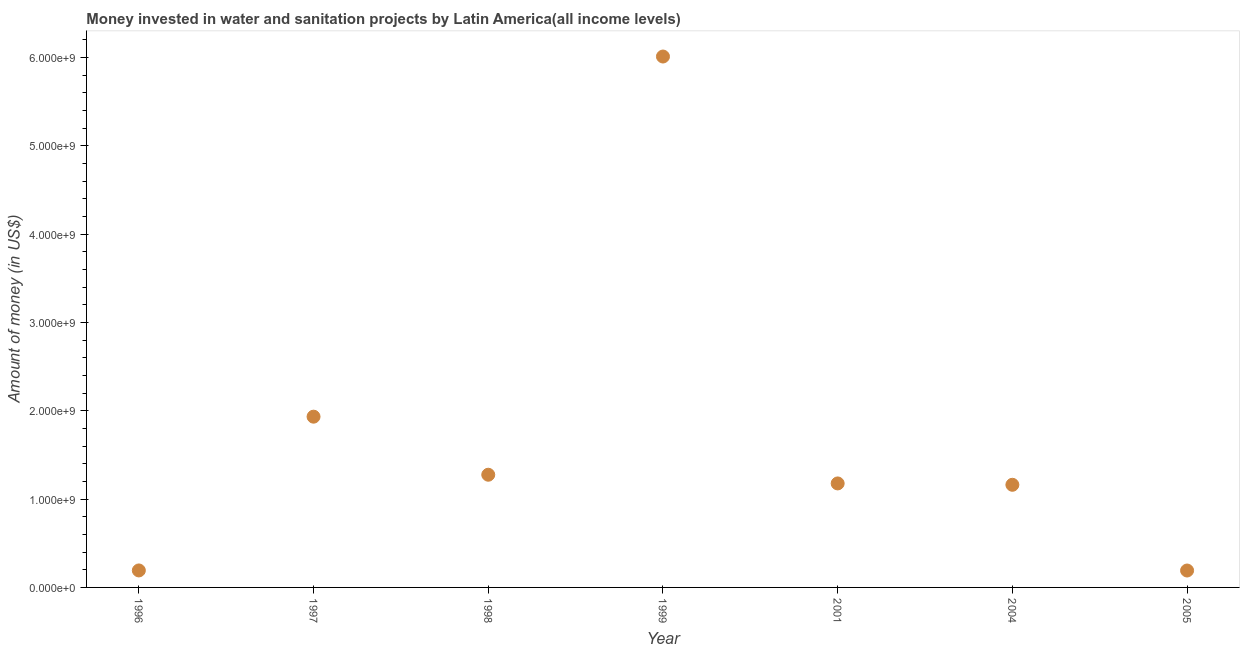What is the investment in 1996?
Make the answer very short. 1.92e+08. Across all years, what is the maximum investment?
Offer a very short reply. 6.01e+09. Across all years, what is the minimum investment?
Provide a succinct answer. 1.91e+08. In which year was the investment maximum?
Provide a succinct answer. 1999. What is the sum of the investment?
Give a very brief answer. 1.19e+1. What is the difference between the investment in 1998 and 2004?
Your answer should be very brief. 1.14e+08. What is the average investment per year?
Your response must be concise. 1.71e+09. What is the median investment?
Your answer should be compact. 1.18e+09. In how many years, is the investment greater than 4600000000 US$?
Provide a short and direct response. 1. Do a majority of the years between 1999 and 2004 (inclusive) have investment greater than 2800000000 US$?
Provide a succinct answer. No. What is the ratio of the investment in 1999 to that in 2005?
Provide a short and direct response. 31.4. Is the difference between the investment in 1996 and 2005 greater than the difference between any two years?
Offer a terse response. No. What is the difference between the highest and the second highest investment?
Your answer should be very brief. 4.08e+09. What is the difference between the highest and the lowest investment?
Your response must be concise. 5.82e+09. In how many years, is the investment greater than the average investment taken over all years?
Ensure brevity in your answer.  2. How many dotlines are there?
Offer a terse response. 1. Does the graph contain grids?
Give a very brief answer. No. What is the title of the graph?
Offer a terse response. Money invested in water and sanitation projects by Latin America(all income levels). What is the label or title of the Y-axis?
Provide a short and direct response. Amount of money (in US$). What is the Amount of money (in US$) in 1996?
Offer a terse response. 1.92e+08. What is the Amount of money (in US$) in 1997?
Make the answer very short. 1.93e+09. What is the Amount of money (in US$) in 1998?
Keep it short and to the point. 1.28e+09. What is the Amount of money (in US$) in 1999?
Keep it short and to the point. 6.01e+09. What is the Amount of money (in US$) in 2001?
Give a very brief answer. 1.18e+09. What is the Amount of money (in US$) in 2004?
Provide a short and direct response. 1.16e+09. What is the Amount of money (in US$) in 2005?
Ensure brevity in your answer.  1.91e+08. What is the difference between the Amount of money (in US$) in 1996 and 1997?
Provide a succinct answer. -1.74e+09. What is the difference between the Amount of money (in US$) in 1996 and 1998?
Your response must be concise. -1.08e+09. What is the difference between the Amount of money (in US$) in 1996 and 1999?
Offer a terse response. -5.82e+09. What is the difference between the Amount of money (in US$) in 1996 and 2001?
Keep it short and to the point. -9.85e+08. What is the difference between the Amount of money (in US$) in 1996 and 2004?
Keep it short and to the point. -9.70e+08. What is the difference between the Amount of money (in US$) in 1996 and 2005?
Offer a terse response. 8.56e+05. What is the difference between the Amount of money (in US$) in 1997 and 1998?
Your answer should be compact. 6.57e+08. What is the difference between the Amount of money (in US$) in 1997 and 1999?
Provide a succinct answer. -4.08e+09. What is the difference between the Amount of money (in US$) in 1997 and 2001?
Make the answer very short. 7.56e+08. What is the difference between the Amount of money (in US$) in 1997 and 2004?
Keep it short and to the point. 7.71e+08. What is the difference between the Amount of money (in US$) in 1997 and 2005?
Your answer should be very brief. 1.74e+09. What is the difference between the Amount of money (in US$) in 1998 and 1999?
Provide a short and direct response. -4.73e+09. What is the difference between the Amount of money (in US$) in 1998 and 2001?
Keep it short and to the point. 9.85e+07. What is the difference between the Amount of money (in US$) in 1998 and 2004?
Your answer should be very brief. 1.14e+08. What is the difference between the Amount of money (in US$) in 1998 and 2005?
Make the answer very short. 1.08e+09. What is the difference between the Amount of money (in US$) in 1999 and 2001?
Keep it short and to the point. 4.83e+09. What is the difference between the Amount of money (in US$) in 1999 and 2004?
Offer a very short reply. 4.85e+09. What is the difference between the Amount of money (in US$) in 1999 and 2005?
Offer a very short reply. 5.82e+09. What is the difference between the Amount of money (in US$) in 2001 and 2004?
Provide a short and direct response. 1.54e+07. What is the difference between the Amount of money (in US$) in 2001 and 2005?
Your answer should be compact. 9.86e+08. What is the difference between the Amount of money (in US$) in 2004 and 2005?
Provide a succinct answer. 9.71e+08. What is the ratio of the Amount of money (in US$) in 1996 to that in 1997?
Your answer should be very brief. 0.1. What is the ratio of the Amount of money (in US$) in 1996 to that in 1998?
Keep it short and to the point. 0.15. What is the ratio of the Amount of money (in US$) in 1996 to that in 1999?
Ensure brevity in your answer.  0.03. What is the ratio of the Amount of money (in US$) in 1996 to that in 2001?
Your response must be concise. 0.16. What is the ratio of the Amount of money (in US$) in 1996 to that in 2004?
Make the answer very short. 0.17. What is the ratio of the Amount of money (in US$) in 1996 to that in 2005?
Your response must be concise. 1. What is the ratio of the Amount of money (in US$) in 1997 to that in 1998?
Your answer should be compact. 1.51. What is the ratio of the Amount of money (in US$) in 1997 to that in 1999?
Offer a terse response. 0.32. What is the ratio of the Amount of money (in US$) in 1997 to that in 2001?
Ensure brevity in your answer.  1.64. What is the ratio of the Amount of money (in US$) in 1997 to that in 2004?
Your answer should be very brief. 1.66. What is the ratio of the Amount of money (in US$) in 1997 to that in 2005?
Offer a terse response. 10.1. What is the ratio of the Amount of money (in US$) in 1998 to that in 1999?
Give a very brief answer. 0.21. What is the ratio of the Amount of money (in US$) in 1998 to that in 2001?
Keep it short and to the point. 1.08. What is the ratio of the Amount of money (in US$) in 1998 to that in 2004?
Provide a succinct answer. 1.1. What is the ratio of the Amount of money (in US$) in 1998 to that in 2005?
Offer a terse response. 6.67. What is the ratio of the Amount of money (in US$) in 1999 to that in 2001?
Offer a very short reply. 5.11. What is the ratio of the Amount of money (in US$) in 1999 to that in 2004?
Make the answer very short. 5.17. What is the ratio of the Amount of money (in US$) in 1999 to that in 2005?
Offer a terse response. 31.4. What is the ratio of the Amount of money (in US$) in 2001 to that in 2005?
Make the answer very short. 6.15. What is the ratio of the Amount of money (in US$) in 2004 to that in 2005?
Provide a short and direct response. 6.07. 